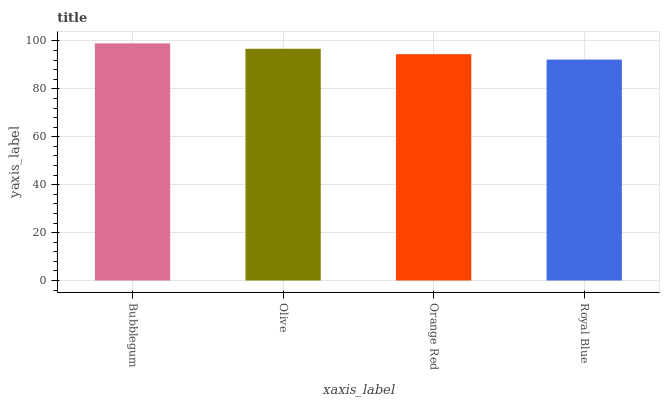Is Royal Blue the minimum?
Answer yes or no. Yes. Is Bubblegum the maximum?
Answer yes or no. Yes. Is Olive the minimum?
Answer yes or no. No. Is Olive the maximum?
Answer yes or no. No. Is Bubblegum greater than Olive?
Answer yes or no. Yes. Is Olive less than Bubblegum?
Answer yes or no. Yes. Is Olive greater than Bubblegum?
Answer yes or no. No. Is Bubblegum less than Olive?
Answer yes or no. No. Is Olive the high median?
Answer yes or no. Yes. Is Orange Red the low median?
Answer yes or no. Yes. Is Royal Blue the high median?
Answer yes or no. No. Is Royal Blue the low median?
Answer yes or no. No. 